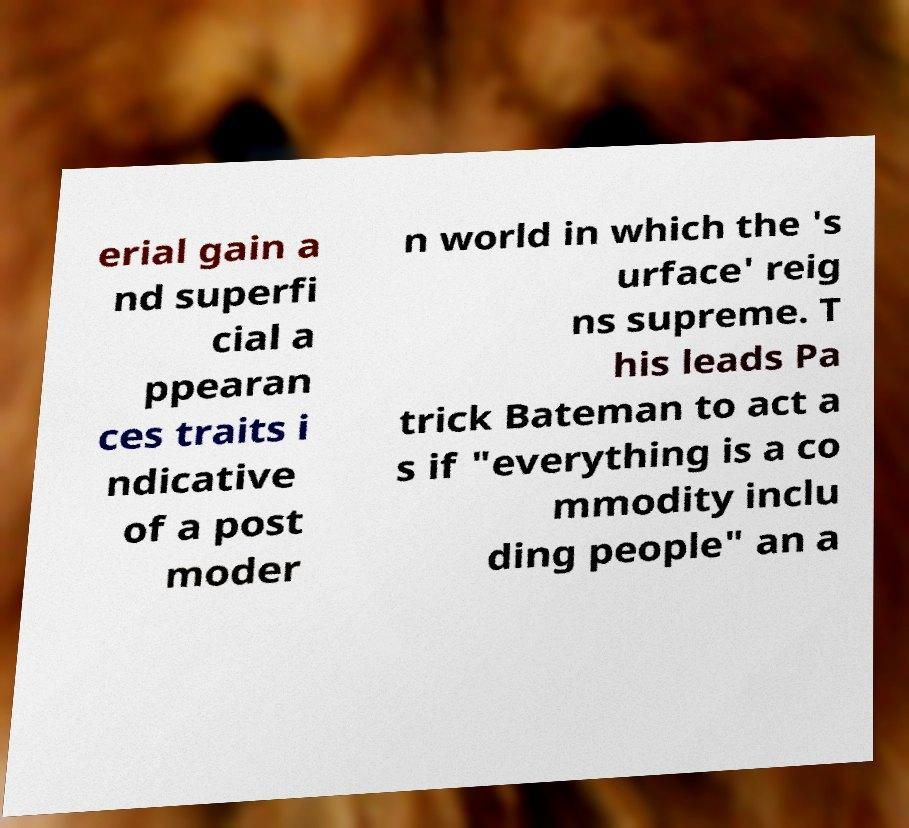What messages or text are displayed in this image? I need them in a readable, typed format. erial gain a nd superfi cial a ppearan ces traits i ndicative of a post moder n world in which the 's urface' reig ns supreme. T his leads Pa trick Bateman to act a s if "everything is a co mmodity inclu ding people" an a 